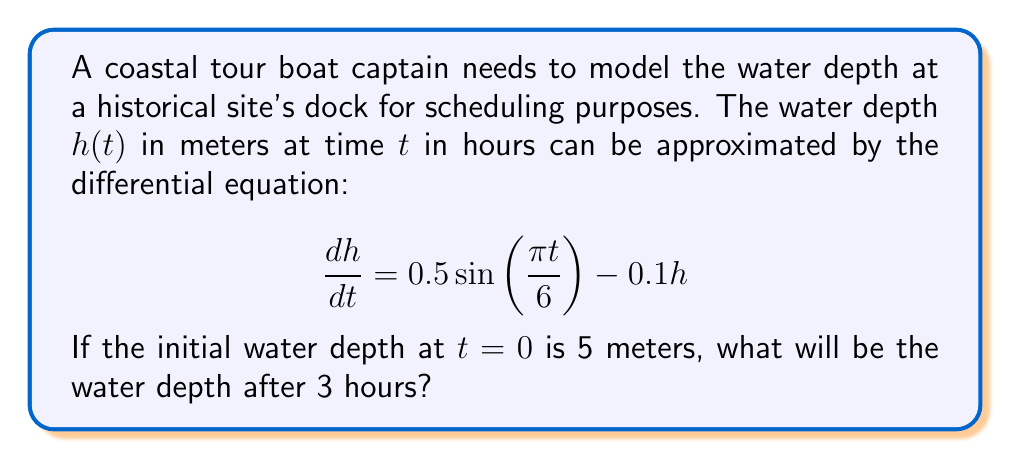Can you answer this question? To solve this problem, we need to use the technique for solving first-order linear differential equations.

1) The general form of a first-order linear differential equation is:

   $$\frac{dy}{dx} + P(x)y = Q(x)$$

2) In our case, $\frac{dh}{dt} + 0.1h = 0.5\sin(\frac{\pi t}{6})$

3) The integrating factor is $e^{\int P(x)dx}$. Here, $P(t) = 0.1$, so:

   $$\mu(t) = e^{\int 0.1 dt} = e^{0.1t}$$

4) Multiply both sides of the equation by $\mu(t)$:

   $$e^{0.1t}\frac{dh}{dt} + 0.1e^{0.1t}h = 0.5e^{0.1t}\sin(\frac{\pi t}{6})$$

5) The left side is now the derivative of $e^{0.1t}h$. So we can write:

   $$\frac{d}{dt}(e^{0.1t}h) = 0.5e^{0.1t}\sin(\frac{\pi t}{6})$$

6) Integrate both sides:

   $$e^{0.1t}h = \int 0.5e^{0.1t}\sin(\frac{\pi t}{6}) dt$$

7) The right side can be integrated using integration by parts. After integration:

   $$e^{0.1t}h = 0.5e^{0.1t}(\frac{6}{\pi}\sin(\frac{\pi t}{6}) - 0.6\cos(\frac{\pi t}{6})) + C$$

8) Solve for $h$:

   $$h = 0.5(\frac{6}{\pi}\sin(\frac{\pi t}{6}) - 0.6\cos(\frac{\pi t}{6})) + Ce^{-0.1t}$$

9) Use the initial condition $h(0) = 5$ to find $C$:

   $$5 = 0.5(-0.6) + C$$
   $$C = 5.3$$

10) The final solution is:

    $$h(t) = 0.5(\frac{6}{\pi}\sin(\frac{\pi t}{6}) - 0.6\cos(\frac{\pi t}{6})) + 5.3e^{-0.1t}$$

11) To find $h(3)$, substitute $t=3$:

    $$h(3) = 0.5(\frac{6}{\pi}\sin(\frac{\pi}{2}) - 0.6\cos(\frac{\pi}{2})) + 5.3e^{-0.3}$$
    $$h(3) = 0.5(\frac{6}{\pi} - 0) + 5.3e^{-0.3}$$
    $$h(3) \approx 4.80 \text{ meters}$$
Answer: 4.80 meters 